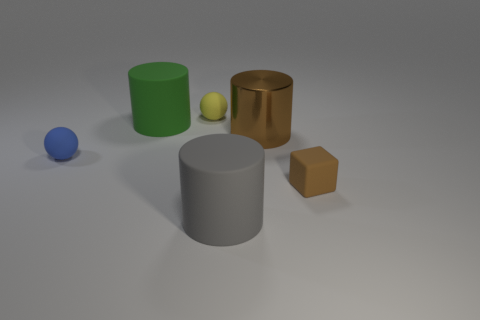Add 4 tiny red cubes. How many objects exist? 10 Subtract all green cylinders. How many cylinders are left? 2 Subtract all brown cylinders. How many cylinders are left? 2 Subtract 1 spheres. How many spheres are left? 1 Subtract all cyan spheres. Subtract all brown cylinders. How many spheres are left? 2 Subtract all brown cubes. How many brown cylinders are left? 1 Subtract all blue objects. Subtract all purple spheres. How many objects are left? 5 Add 4 small brown matte blocks. How many small brown matte blocks are left? 5 Add 5 tiny things. How many tiny things exist? 8 Subtract 0 green cubes. How many objects are left? 6 